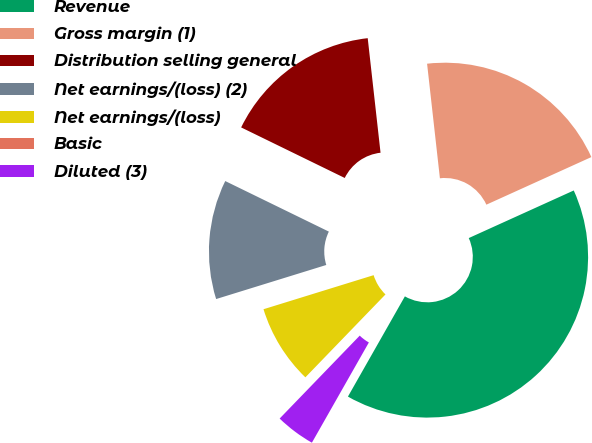Convert chart. <chart><loc_0><loc_0><loc_500><loc_500><pie_chart><fcel>Revenue<fcel>Gross margin (1)<fcel>Distribution selling general<fcel>Net earnings/(loss) (2)<fcel>Net earnings/(loss)<fcel>Basic<fcel>Diluted (3)<nl><fcel>40.0%<fcel>20.0%<fcel>16.0%<fcel>12.0%<fcel>8.0%<fcel>0.0%<fcel>4.0%<nl></chart> 